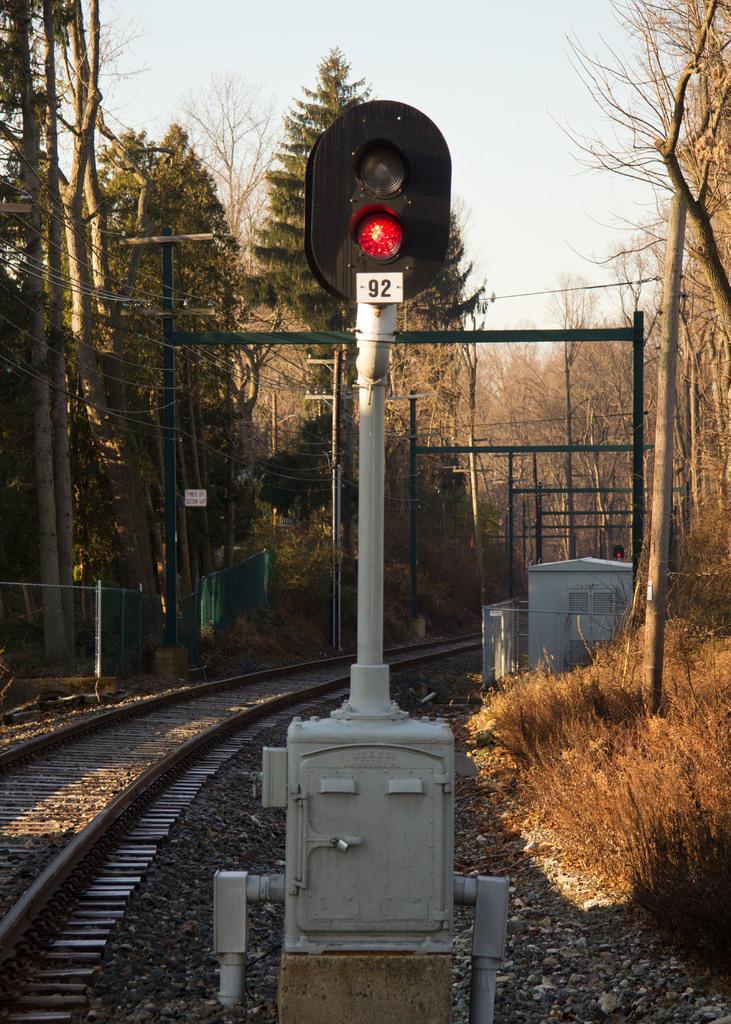How would you summarize this image in a sentence or two? In this picture there traffic pole in the center of the image and there are tracks on the left side of the image and there are dried trees in the background area of the image, there are towers in the image. 